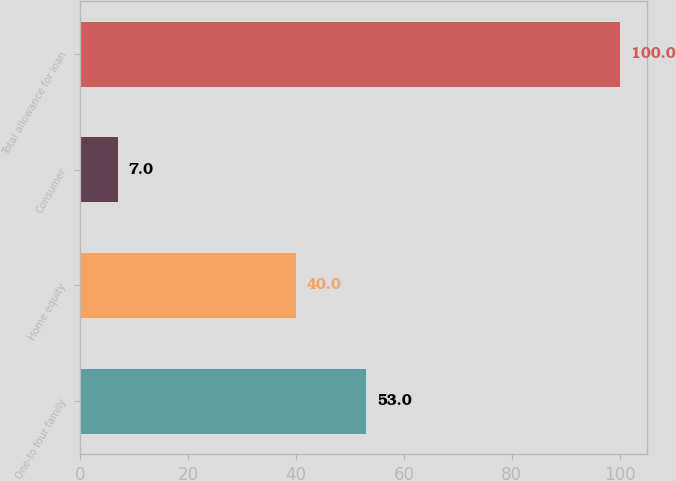<chart> <loc_0><loc_0><loc_500><loc_500><bar_chart><fcel>One-to four family<fcel>Home equity<fcel>Consumer<fcel>Total allowance for loan<nl><fcel>53<fcel>40<fcel>7<fcel>100<nl></chart> 